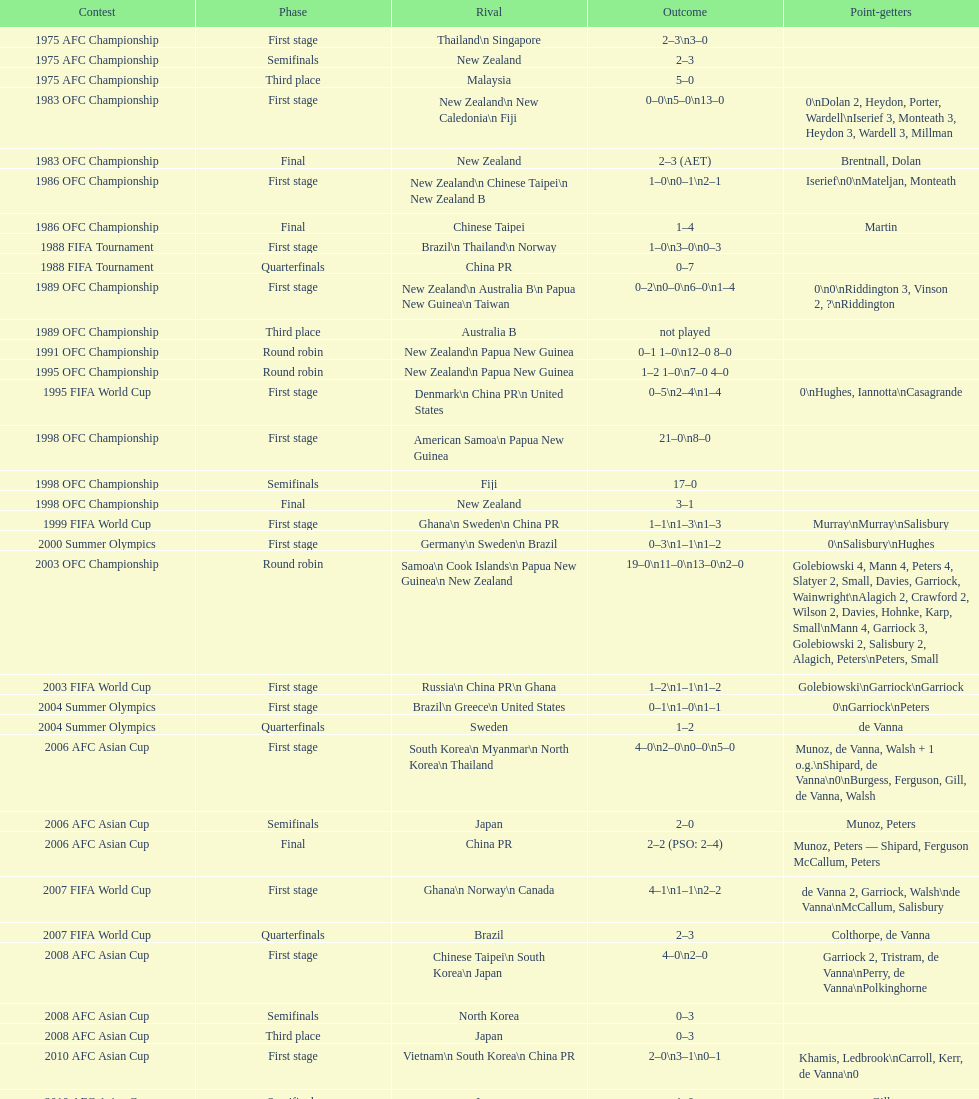What is the difference in the number of goals scored in the 1999 fifa world cup and the 2000 summer olympics? 2. 